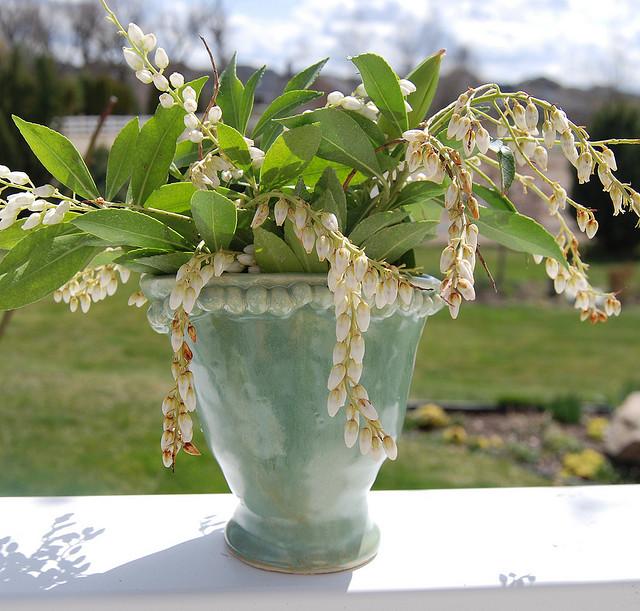What are those beads on the glass?
Keep it brief. Decoration. Where are the leaf's?
Concise answer only. Vase. What kind of plant is this?
Short answer required. Lily. Is the table white?
Answer briefly. Yes. 